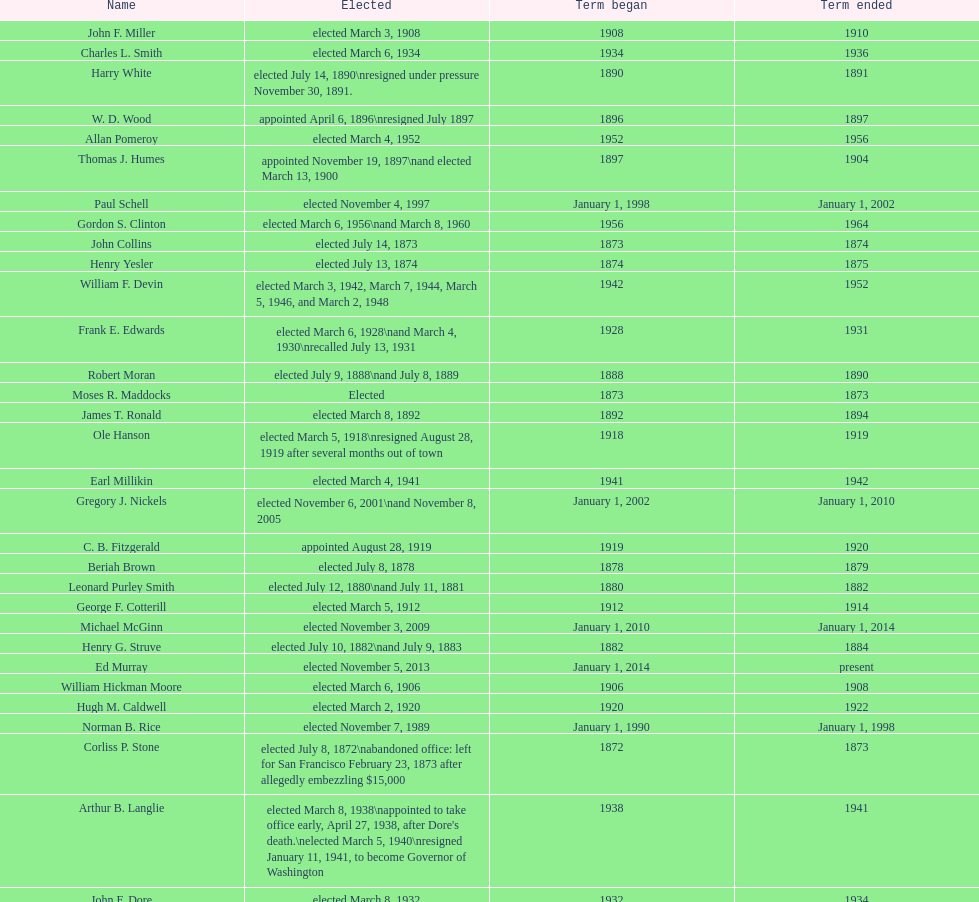Who was the first mayor in the 1900's? Richard A. Ballinger. 